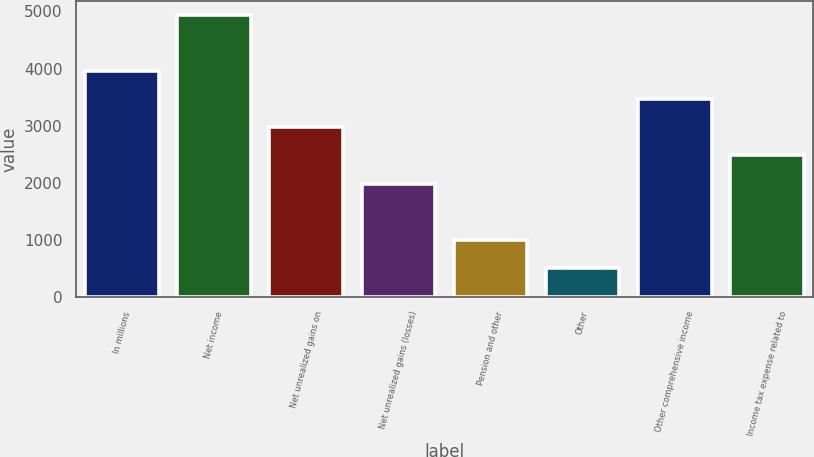Convert chart. <chart><loc_0><loc_0><loc_500><loc_500><bar_chart><fcel>In millions<fcel>Net income<fcel>Net unrealized gains on<fcel>Net unrealized gains (losses)<fcel>Pension and other<fcel>Other<fcel>Other comprehensive income<fcel>Income tax expense related to<nl><fcel>3957.4<fcel>4943<fcel>2971.8<fcel>1986.2<fcel>1000.6<fcel>507.8<fcel>3464.6<fcel>2479<nl></chart> 